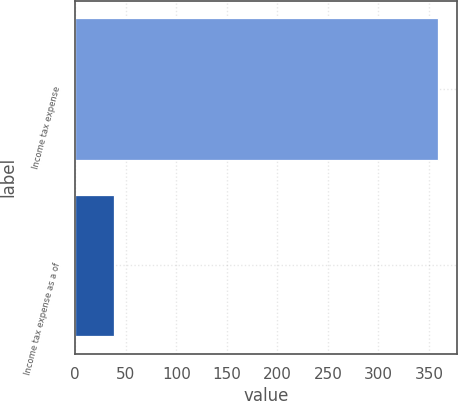<chart> <loc_0><loc_0><loc_500><loc_500><bar_chart><fcel>Income tax expense<fcel>Income tax expense as a of<nl><fcel>359.4<fcel>38.1<nl></chart> 